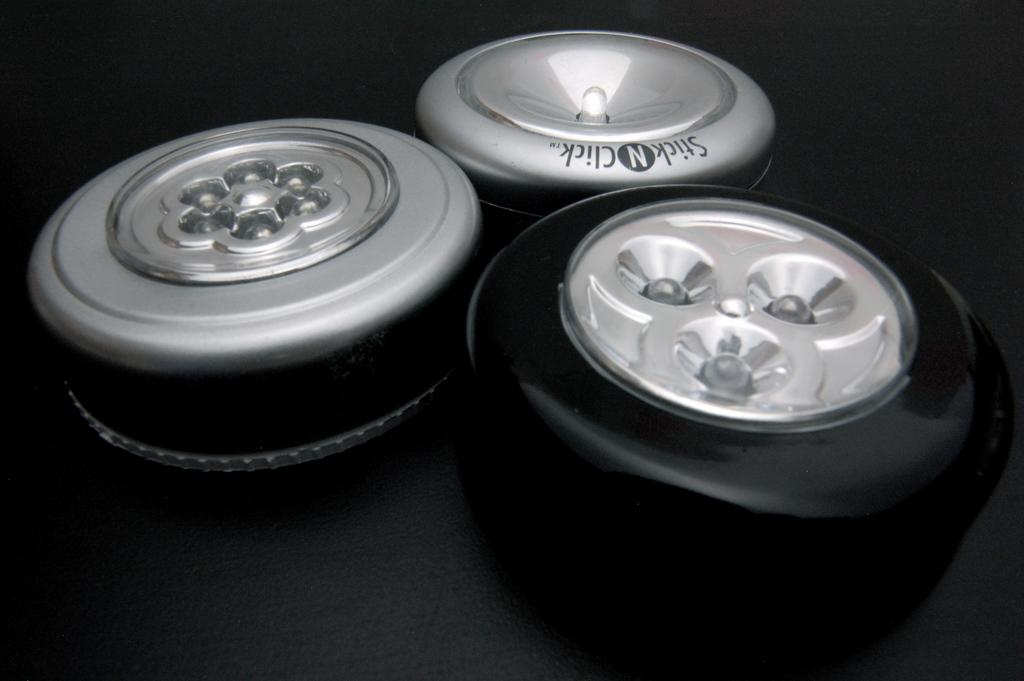What type of lighting is present in the image? There are LED lights in the image. What can be observed about the background of the image? The background of the image is dark. What type of rabbit can be seen in the image? There is no rabbit present in the image. What is the desire of the person in the image? There is no person present in the image, so it is impossible to determine their desires. 